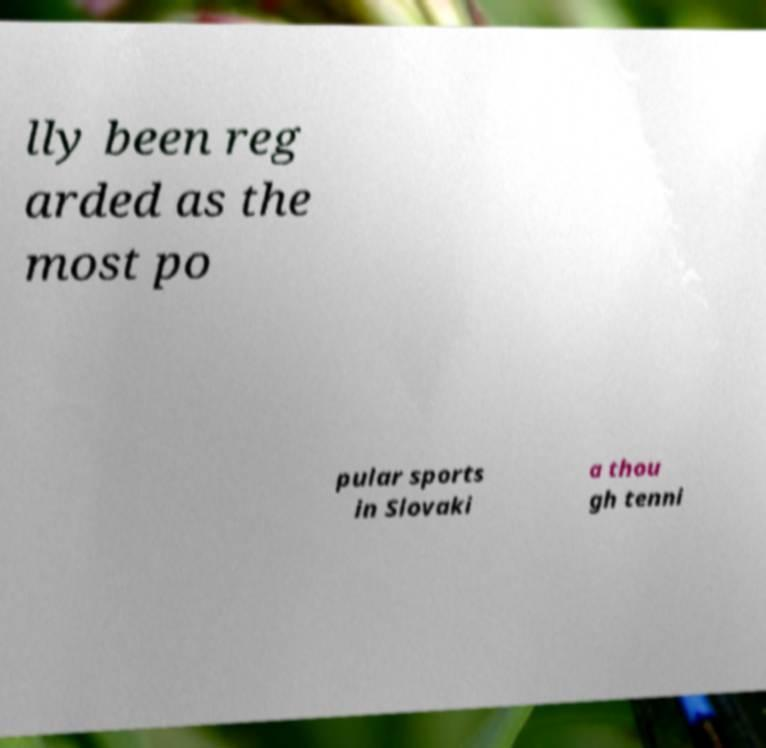Can you read and provide the text displayed in the image?This photo seems to have some interesting text. Can you extract and type it out for me? lly been reg arded as the most po pular sports in Slovaki a thou gh tenni 